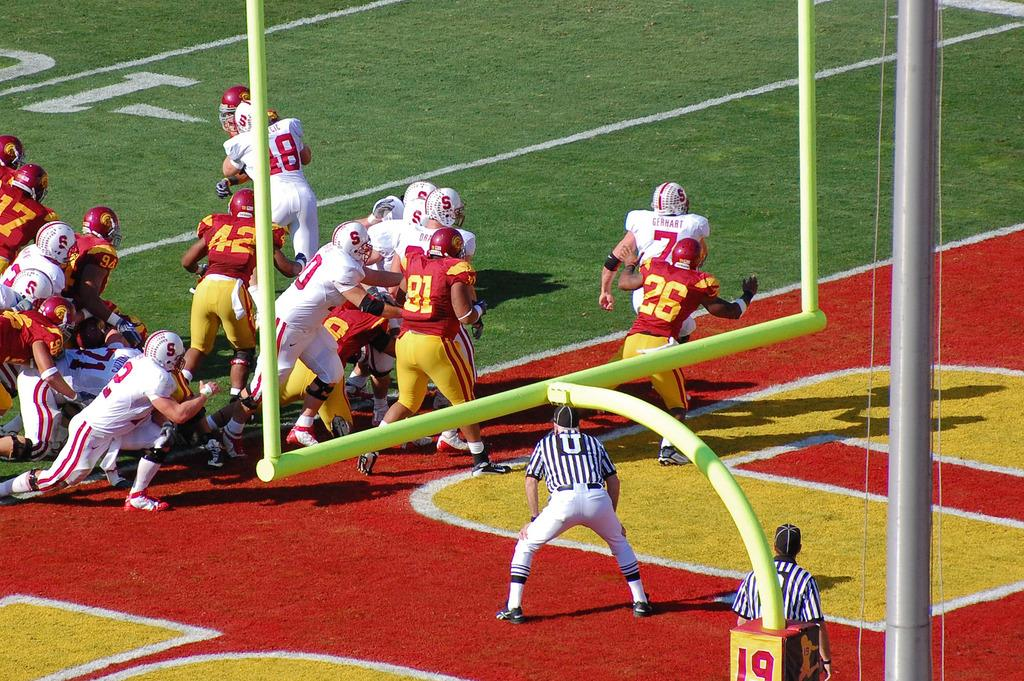What is happening in the image involving a group of people? In the image, a group of people are playing in a playground. What are the people wearing that might provide protection? The people are wearing helmets for protection. Who is present to ensure the game is played fairly? There are referees in the image to ensure the game is played fairly. What structures can be seen in the playground? There are poles in the image. What markings are on the ground in the image? There are signs on the ground in the image. What type of leather is being used by the people in the image? There is no leather visible in the image; the people are wearing helmets made of other materials. 